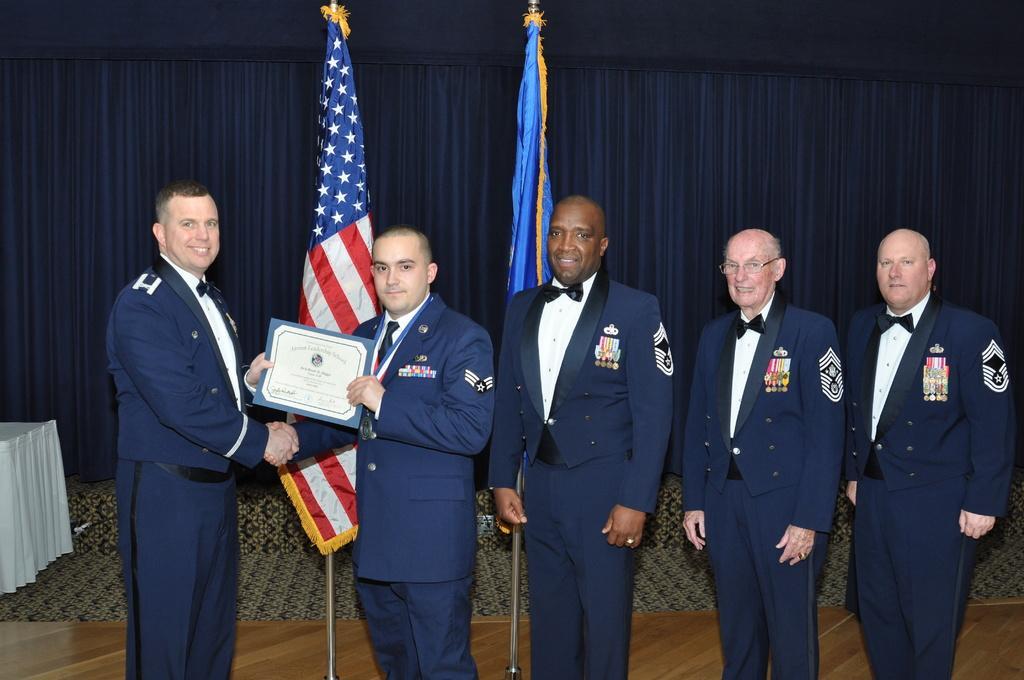In one or two sentences, can you explain what this image depicts? In this picture I can see there are a group of people standing and they are wearing a blazer and the people on left are holding a certificate and shaking their hands and in the backdrop there are two flags and there is a blue color curtain. 